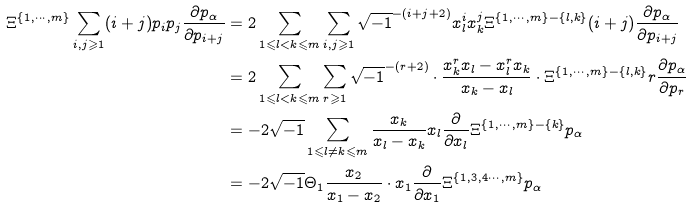Convert formula to latex. <formula><loc_0><loc_0><loc_500><loc_500>\Xi ^ { \{ 1 , \cdots , m \} } \sum _ { i , j \geqslant 1 } ( i + j ) p _ { i } p _ { j } \frac { \partial p _ { \alpha } } { \partial p _ { i + j } } & = 2 \sum _ { 1 \leqslant l < k \leqslant m } \sum _ { i , j \geqslant 1 } \sqrt { - 1 } ^ { - ( i + j + 2 ) } x _ { l } ^ { i } x _ { k } ^ { j } \Xi ^ { \{ 1 , \cdots , m \} - \{ l , k \} } ( i + j ) \frac { \partial p _ { \alpha } } { \partial p _ { i + j } } \\ & = 2 \sum _ { 1 \leqslant l < k \leqslant m } \sum _ { r \geqslant 1 } \sqrt { - 1 } ^ { - ( r + 2 ) } \cdot \frac { x _ { k } ^ { r } x _ { l } - x _ { l } ^ { r } x _ { k } } { x _ { k } - x _ { l } } \cdot \Xi ^ { \{ 1 , \cdots , m \} - \{ l , k \} } r \frac { \partial p _ { \alpha } } { \partial p _ { r } } \\ & = - 2 \sqrt { - 1 } \sum _ { 1 \leqslant l \neq k \leqslant m } \frac { x _ { k } } { x _ { l } - x _ { k } } x _ { l } \frac { \partial } { \partial x _ { l } } \Xi ^ { \{ 1 , \cdots , m \} - \{ k \} } p _ { \alpha } \\ & = - 2 \sqrt { - 1 } \Theta _ { 1 } \frac { x _ { 2 } } { x _ { 1 } - x _ { 2 } } \cdot x _ { 1 } \frac { \partial } { \partial x _ { 1 } } \Xi ^ { \{ 1 , 3 , 4 \cdots , m \} } p _ { \alpha }</formula> 